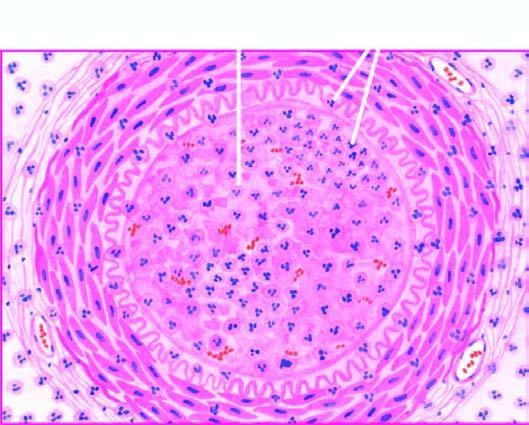what is occluded by a thrombus containing microabscesses?
Answer the question using a single word or phrase. The lumen 